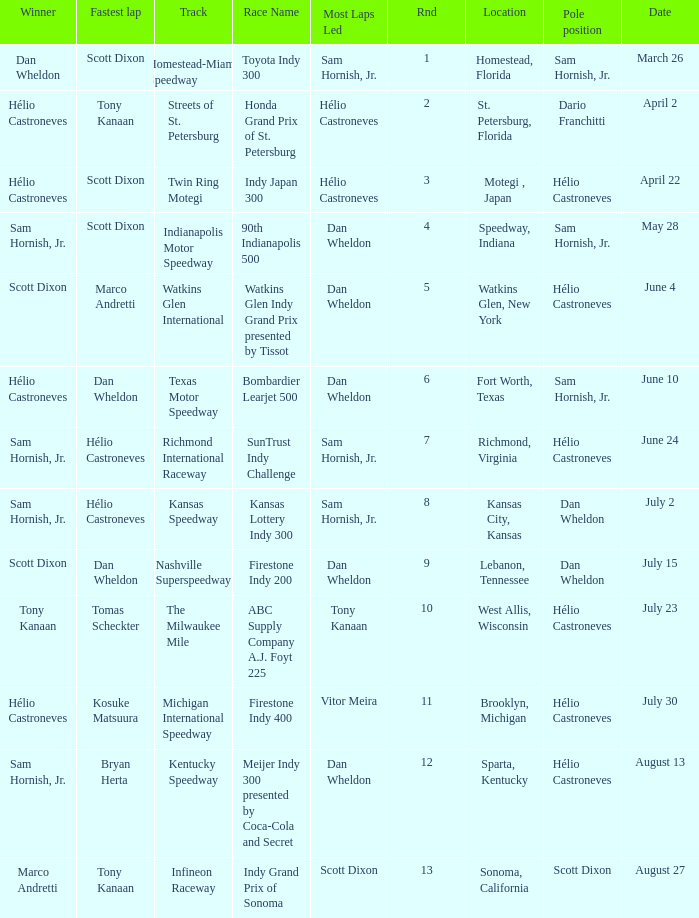How many times is the location is homestead, florida? 1.0. 